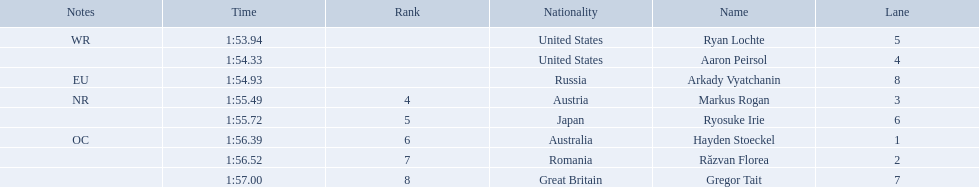Who are the swimmers? Ryan Lochte, Aaron Peirsol, Arkady Vyatchanin, Markus Rogan, Ryosuke Irie, Hayden Stoeckel, Răzvan Florea, Gregor Tait. What is ryosuke irie's time? 1:55.72. 